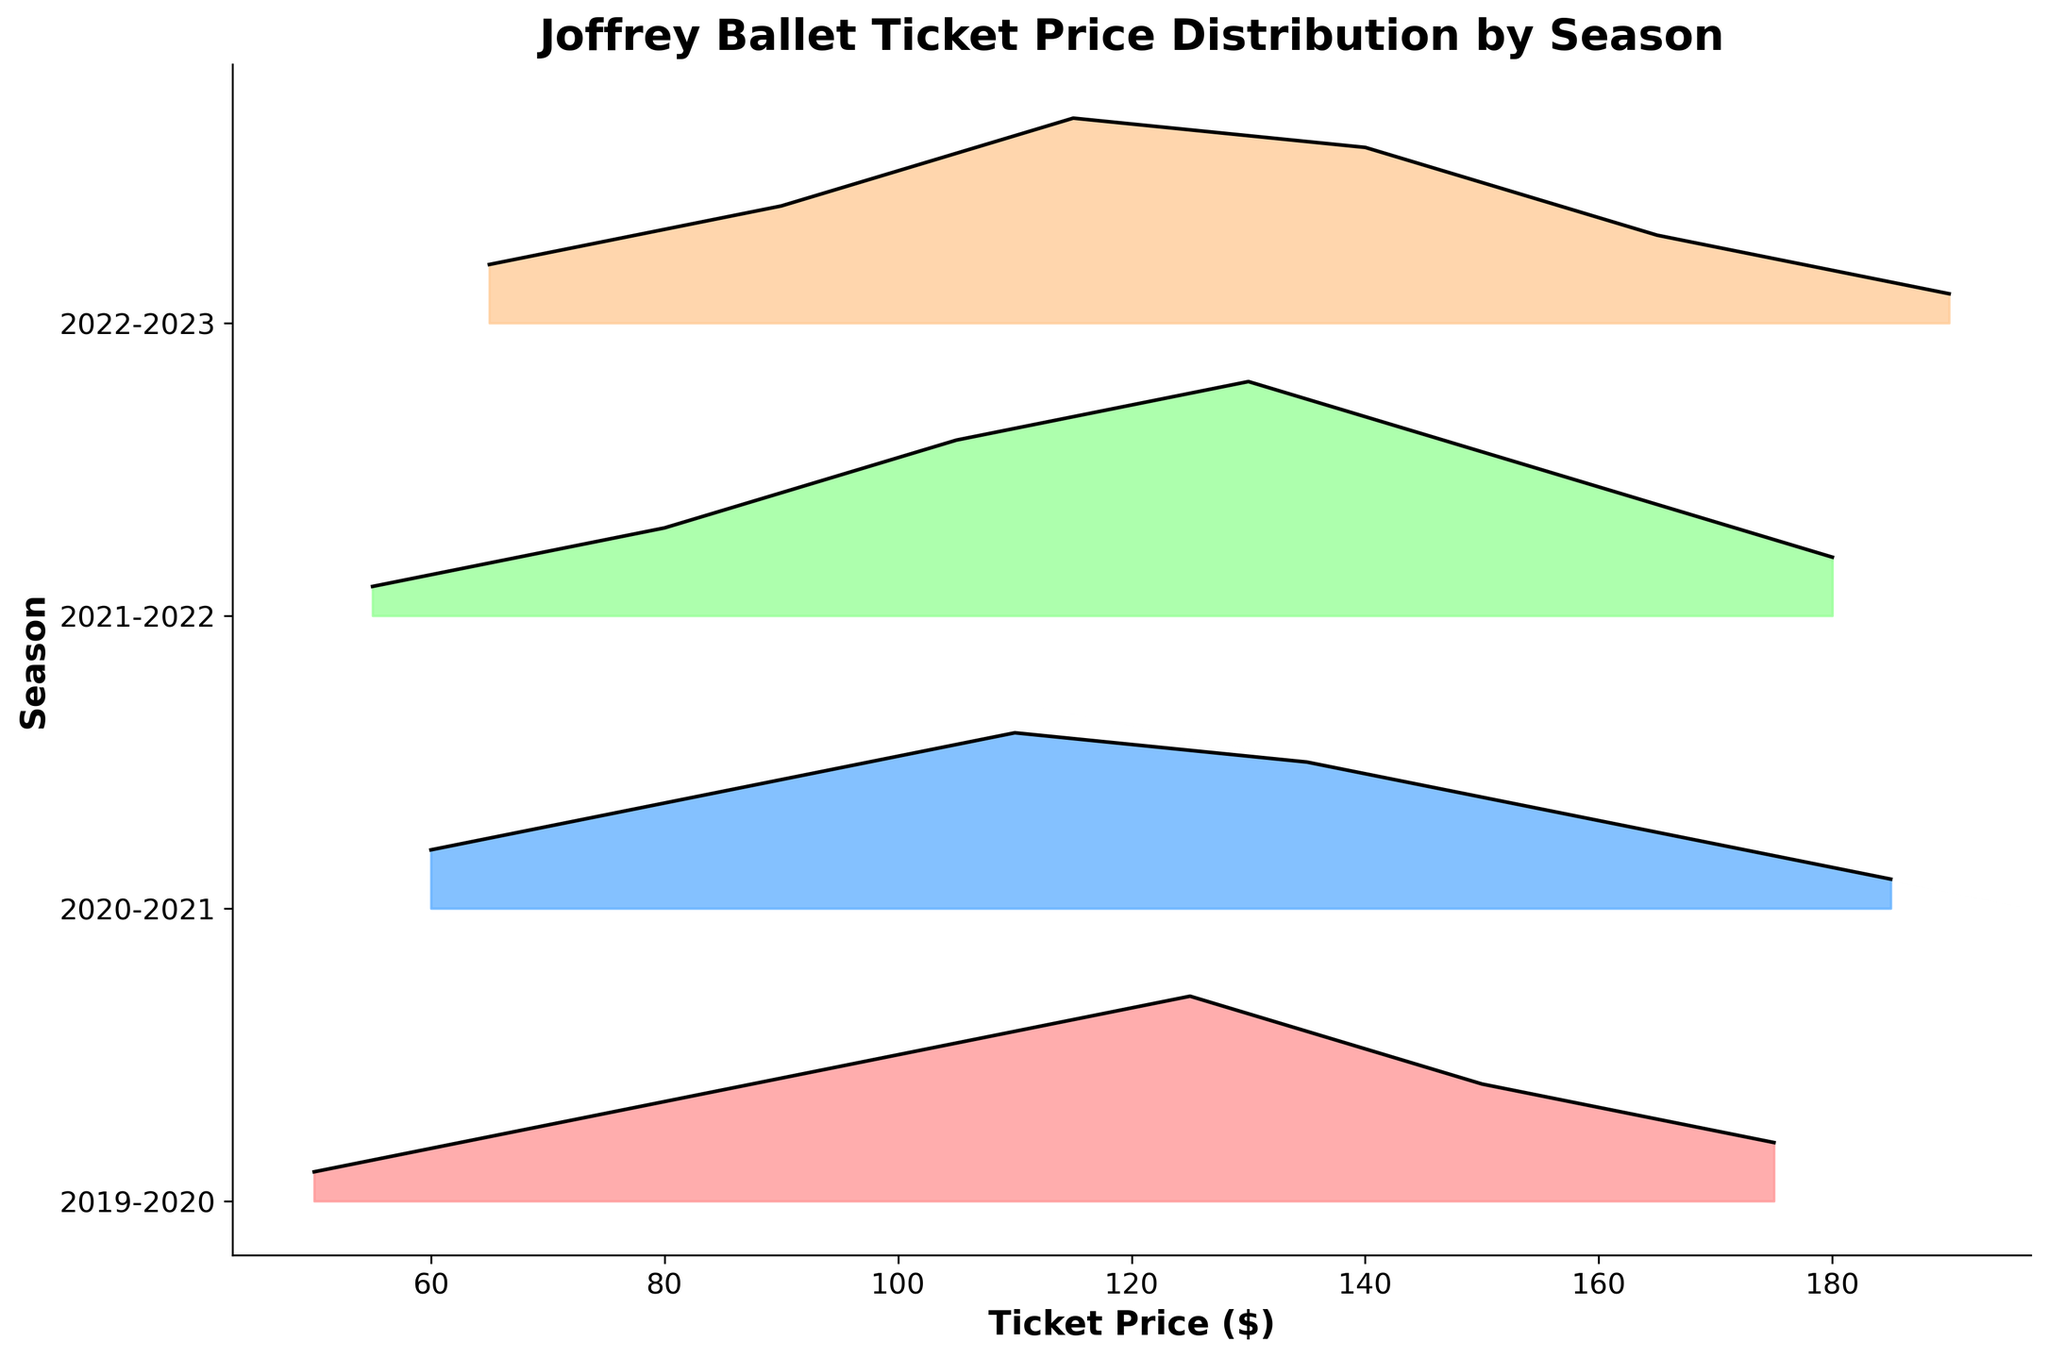What is the title of the plot? The title of a plot is usually found at the top of the figure. The title here is recorded in the `ax.set_title` function. Looking at the subplot configuration, the title is clearly shown.
Answer: Joffrey Ballet Ticket Price Distribution by Season What seasons are compared in this plot? The seasons compared in the plot are labeled on the y-axis. They are: 2019-2020, 2020-2021, 2021-2022, and 2022-2023.
Answer: 2019-2020, 2020-2021, 2021-2022, 2022-2023 Which season shows the highest density of ticket prices around $130? By looking at the y-axis labels and the filled densities along the x-axis at around $130, the 2021-2022 season has the highest density at that price level.
Answer: 2021-2022 What is the range of ticket prices shown on the x-axis? The x-axis labels the ticket prices ranging from the minimum value on the left to the maximum value on the right. The recorded data includes prices from $50 to $190.
Answer: $50 to $190 Which season has the lowest density peak? By examining the peaks of density curves for each season and comparing their heights (with respect to the y-axis marking), the 2019-2020 season has the lowest density peak.
Answer: 2019-2020 How does the density of ticket prices at $110 in the 2020-2021 season compare to the density at the same price in other seasons? Compare the height of the density curve at the $110 price across all seasons by looking at the plot. The density for 2020-2021 at $110 is higher in comparison to other seasons except for 2022-2023 which is slightly higher.
Answer: 2022-2023 > 2020-2021 > 2021-2022 > 2019-2020 What can you infer about the overall variability of ticket prices across seasons? By observing the spread and peaks of density curves for each season, we see some seasons like 2021-2022 and 2022-2023 have wider distributions and higher peak densities, whereas others like 2019-2020 have narrower distributions. This suggests more variability in the latter seasons.
Answer: More variability in 2021-2022 and 2022-2023 Which season shows a shift towards higher ticket prices compared to the others? By locating where the peaks of density curves move towards higher prices on the x-axis, 2022-2023 season shows a noticeable shift towards higher prices compared to earlier seasons.
Answer: 2022-2023 What is the color scheme used for the seasons, and does it help in differentiating them visually? The color scheme is indicated by different tones assigned to each line in order based on seasons. The custom colormap used indicates distinct colors for each season, aiding visual differentiation.
Answer: Yes 